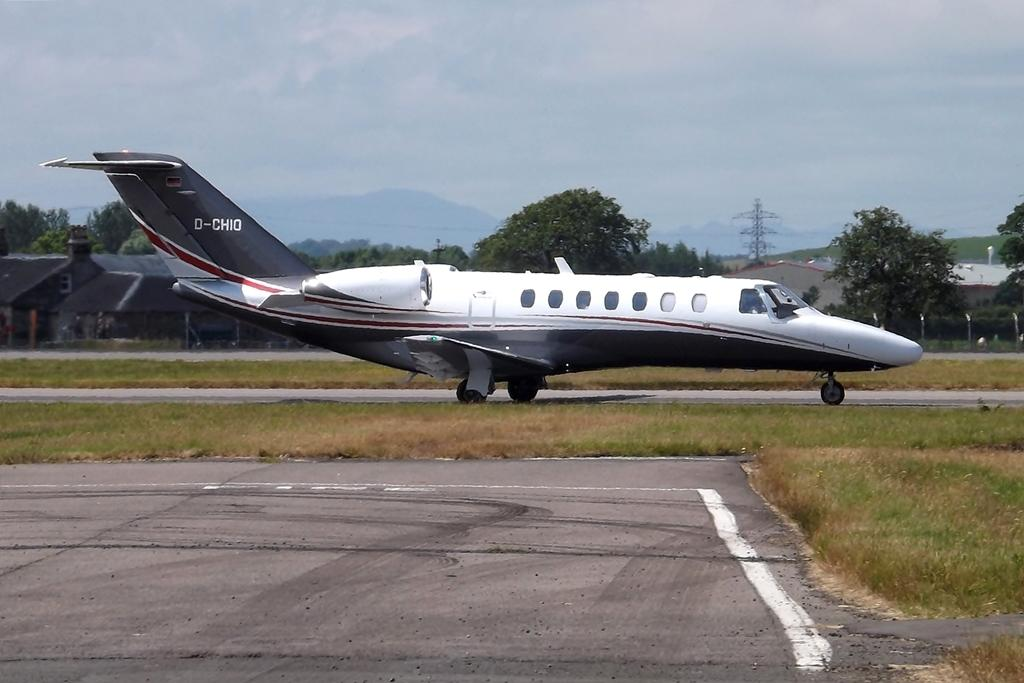Provide a one-sentence caption for the provided image. D-CHIO is the flight number painted onto the side of this passenger jet. 